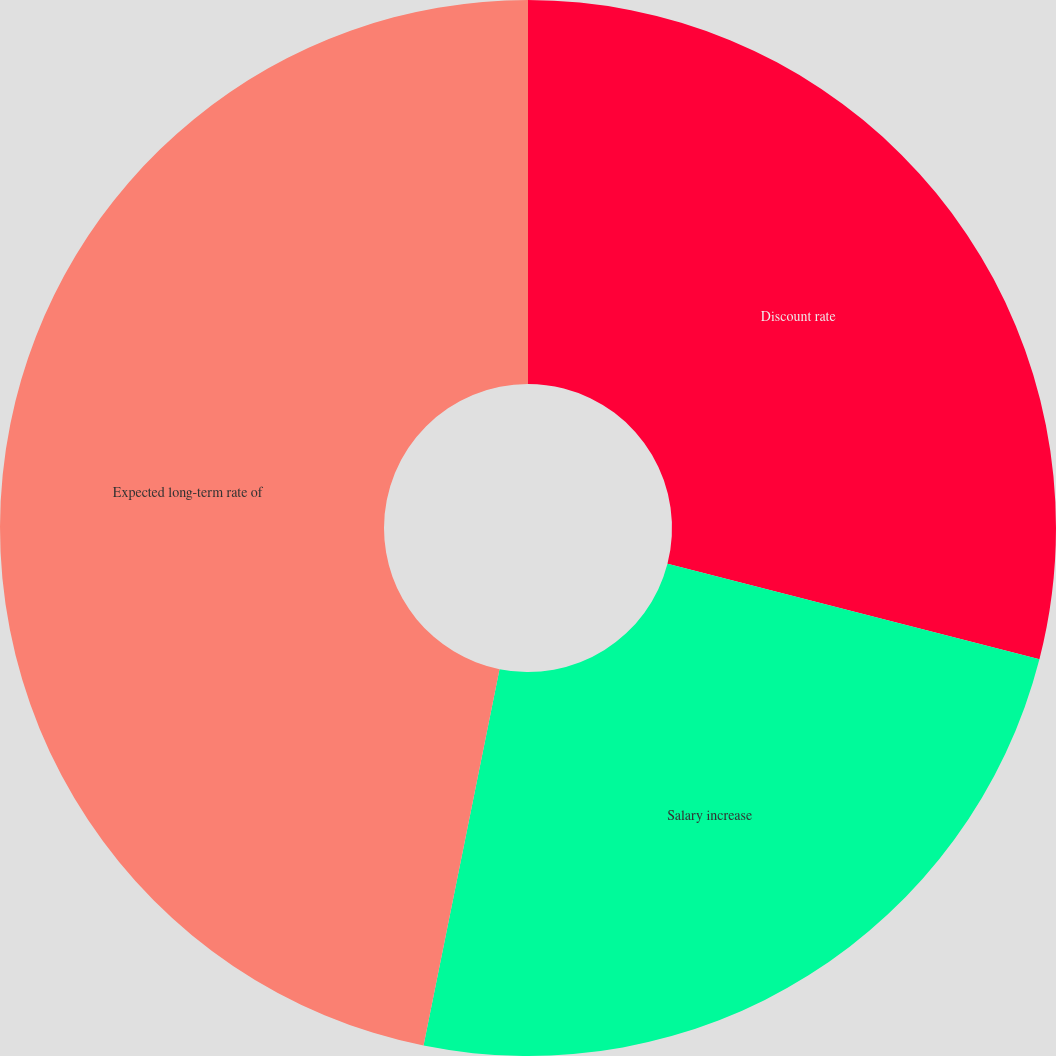<chart> <loc_0><loc_0><loc_500><loc_500><pie_chart><fcel>Discount rate<fcel>Salary increase<fcel>Expected long-term rate of<nl><fcel>29.0%<fcel>24.17%<fcel>46.83%<nl></chart> 